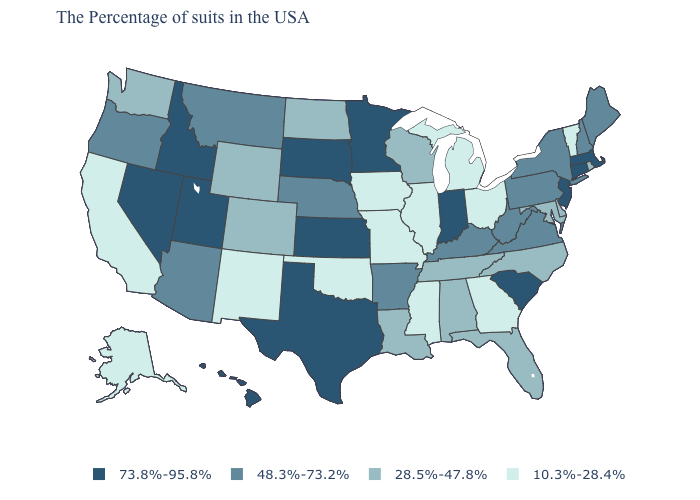Does Arizona have the highest value in the West?
Answer briefly. No. What is the value of Utah?
Quick response, please. 73.8%-95.8%. Name the states that have a value in the range 28.5%-47.8%?
Give a very brief answer. Rhode Island, Delaware, Maryland, North Carolina, Florida, Alabama, Tennessee, Wisconsin, Louisiana, North Dakota, Wyoming, Colorado, Washington. What is the highest value in the USA?
Write a very short answer. 73.8%-95.8%. Does West Virginia have a higher value than Rhode Island?
Quick response, please. Yes. Which states have the highest value in the USA?
Write a very short answer. Massachusetts, Connecticut, New Jersey, South Carolina, Indiana, Minnesota, Kansas, Texas, South Dakota, Utah, Idaho, Nevada, Hawaii. Among the states that border Utah , does New Mexico have the lowest value?
Give a very brief answer. Yes. Does Arkansas have a lower value than Montana?
Short answer required. No. What is the value of Florida?
Answer briefly. 28.5%-47.8%. What is the highest value in the MidWest ?
Short answer required. 73.8%-95.8%. What is the value of Nevada?
Keep it brief. 73.8%-95.8%. Which states hav the highest value in the Northeast?
Keep it brief. Massachusetts, Connecticut, New Jersey. What is the value of New Hampshire?
Concise answer only. 48.3%-73.2%. Name the states that have a value in the range 28.5%-47.8%?
Quick response, please. Rhode Island, Delaware, Maryland, North Carolina, Florida, Alabama, Tennessee, Wisconsin, Louisiana, North Dakota, Wyoming, Colorado, Washington. 